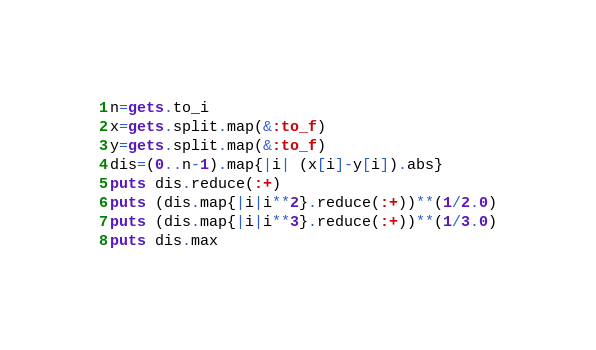<code> <loc_0><loc_0><loc_500><loc_500><_Ruby_>n=gets.to_i
x=gets.split.map(&:to_f)
y=gets.split.map(&:to_f)
dis=(0..n-1).map{|i| (x[i]-y[i]).abs}
puts dis.reduce(:+)
puts (dis.map{|i|i**2}.reduce(:+))**(1/2.0)
puts (dis.map{|i|i**3}.reduce(:+))**(1/3.0)
puts dis.max</code> 